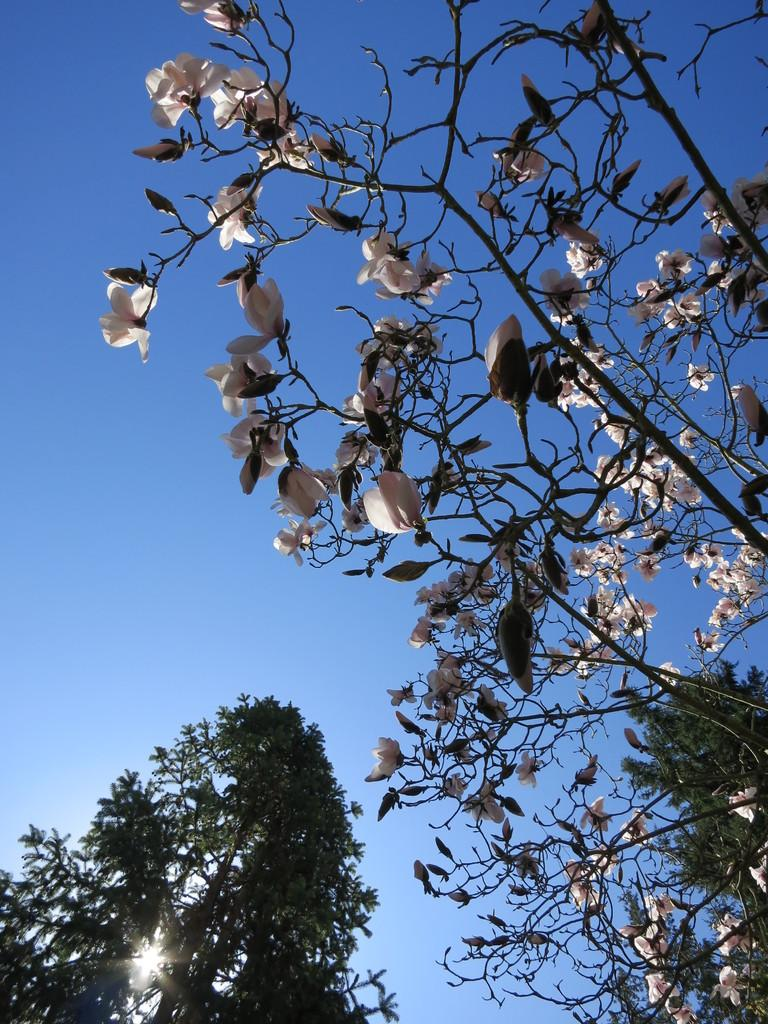What type of vegetation can be seen in the image? There are trees in the image. What is visible in the background of the image? The sky is visible in the background of the image. Can the sun be seen in the image? Yes, the sun is observable in the sky. What type of record can be seen in the image? There is no record present in the image; it features trees and a sky with the sun. Is there any trouble visible in the image? There is no indication of trouble in the image; it shows a peaceful scene with trees, sky, and the sun. 